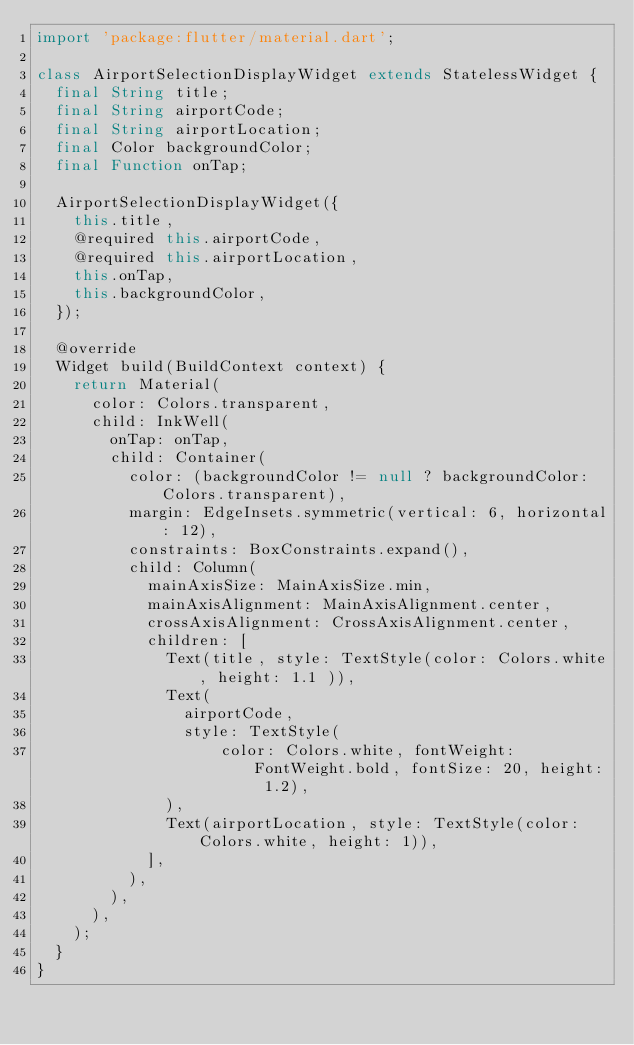<code> <loc_0><loc_0><loc_500><loc_500><_Dart_>import 'package:flutter/material.dart';

class AirportSelectionDisplayWidget extends StatelessWidget {
  final String title;
  final String airportCode;
  final String airportLocation;
  final Color backgroundColor;
  final Function onTap;

  AirportSelectionDisplayWidget({
    this.title,
    @required this.airportCode,
    @required this.airportLocation,
    this.onTap,
    this.backgroundColor,
  });

  @override
  Widget build(BuildContext context) {
    return Material(
      color: Colors.transparent,
      child: InkWell(
        onTap: onTap,
        child: Container(
          color: (backgroundColor != null ? backgroundColor: Colors.transparent),
          margin: EdgeInsets.symmetric(vertical: 6, horizontal: 12),
          constraints: BoxConstraints.expand(),
          child: Column(
            mainAxisSize: MainAxisSize.min,
            mainAxisAlignment: MainAxisAlignment.center,
            crossAxisAlignment: CrossAxisAlignment.center,
            children: [
              Text(title, style: TextStyle(color: Colors.white, height: 1.1 )),
              Text(
                airportCode,
                style: TextStyle(
                    color: Colors.white, fontWeight: FontWeight.bold, fontSize: 20, height: 1.2),
              ),
              Text(airportLocation, style: TextStyle(color: Colors.white, height: 1)),
            ],
          ),
        ),
      ),
    );
  }
}
</code> 